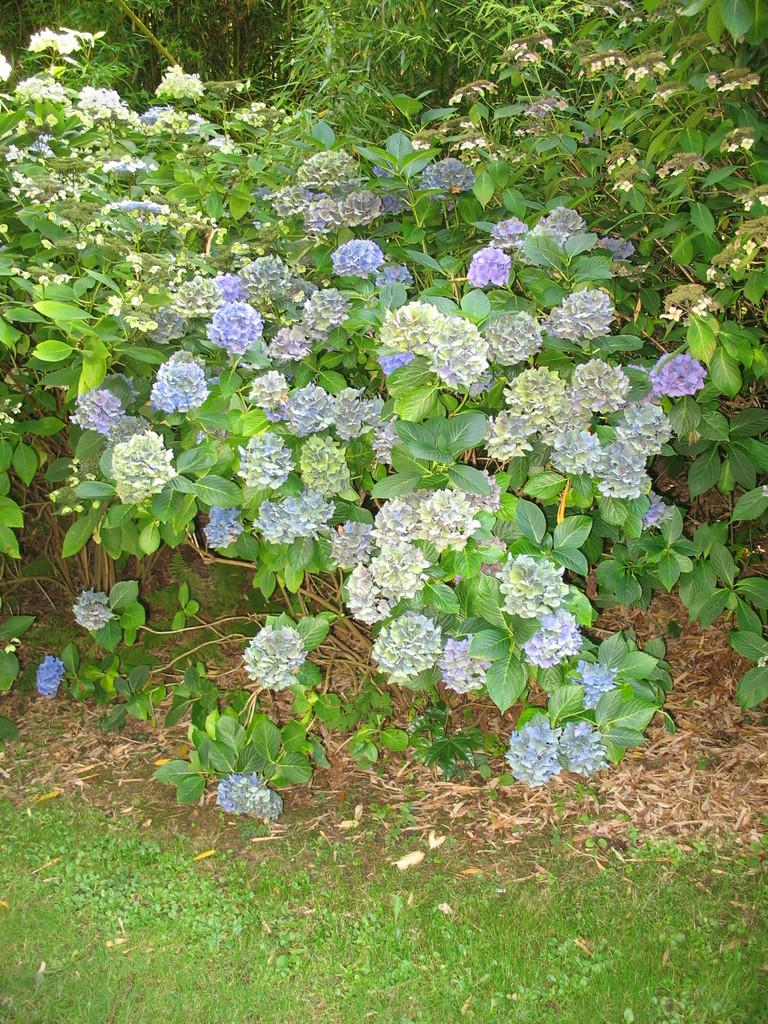What type of plant life is visible in the image? There are flowers in the image. Can you describe the flowers in more detail? The flowers have leaves and stems. What else can be seen in the background of the image? There are plants in the background of the image. What type of ground cover is present at the bottom of the image? There is grass at the bottom of the image. What type of fuel is being used by the flowers in the image? There is no indication in the image that the flowers are using any type of fuel. 